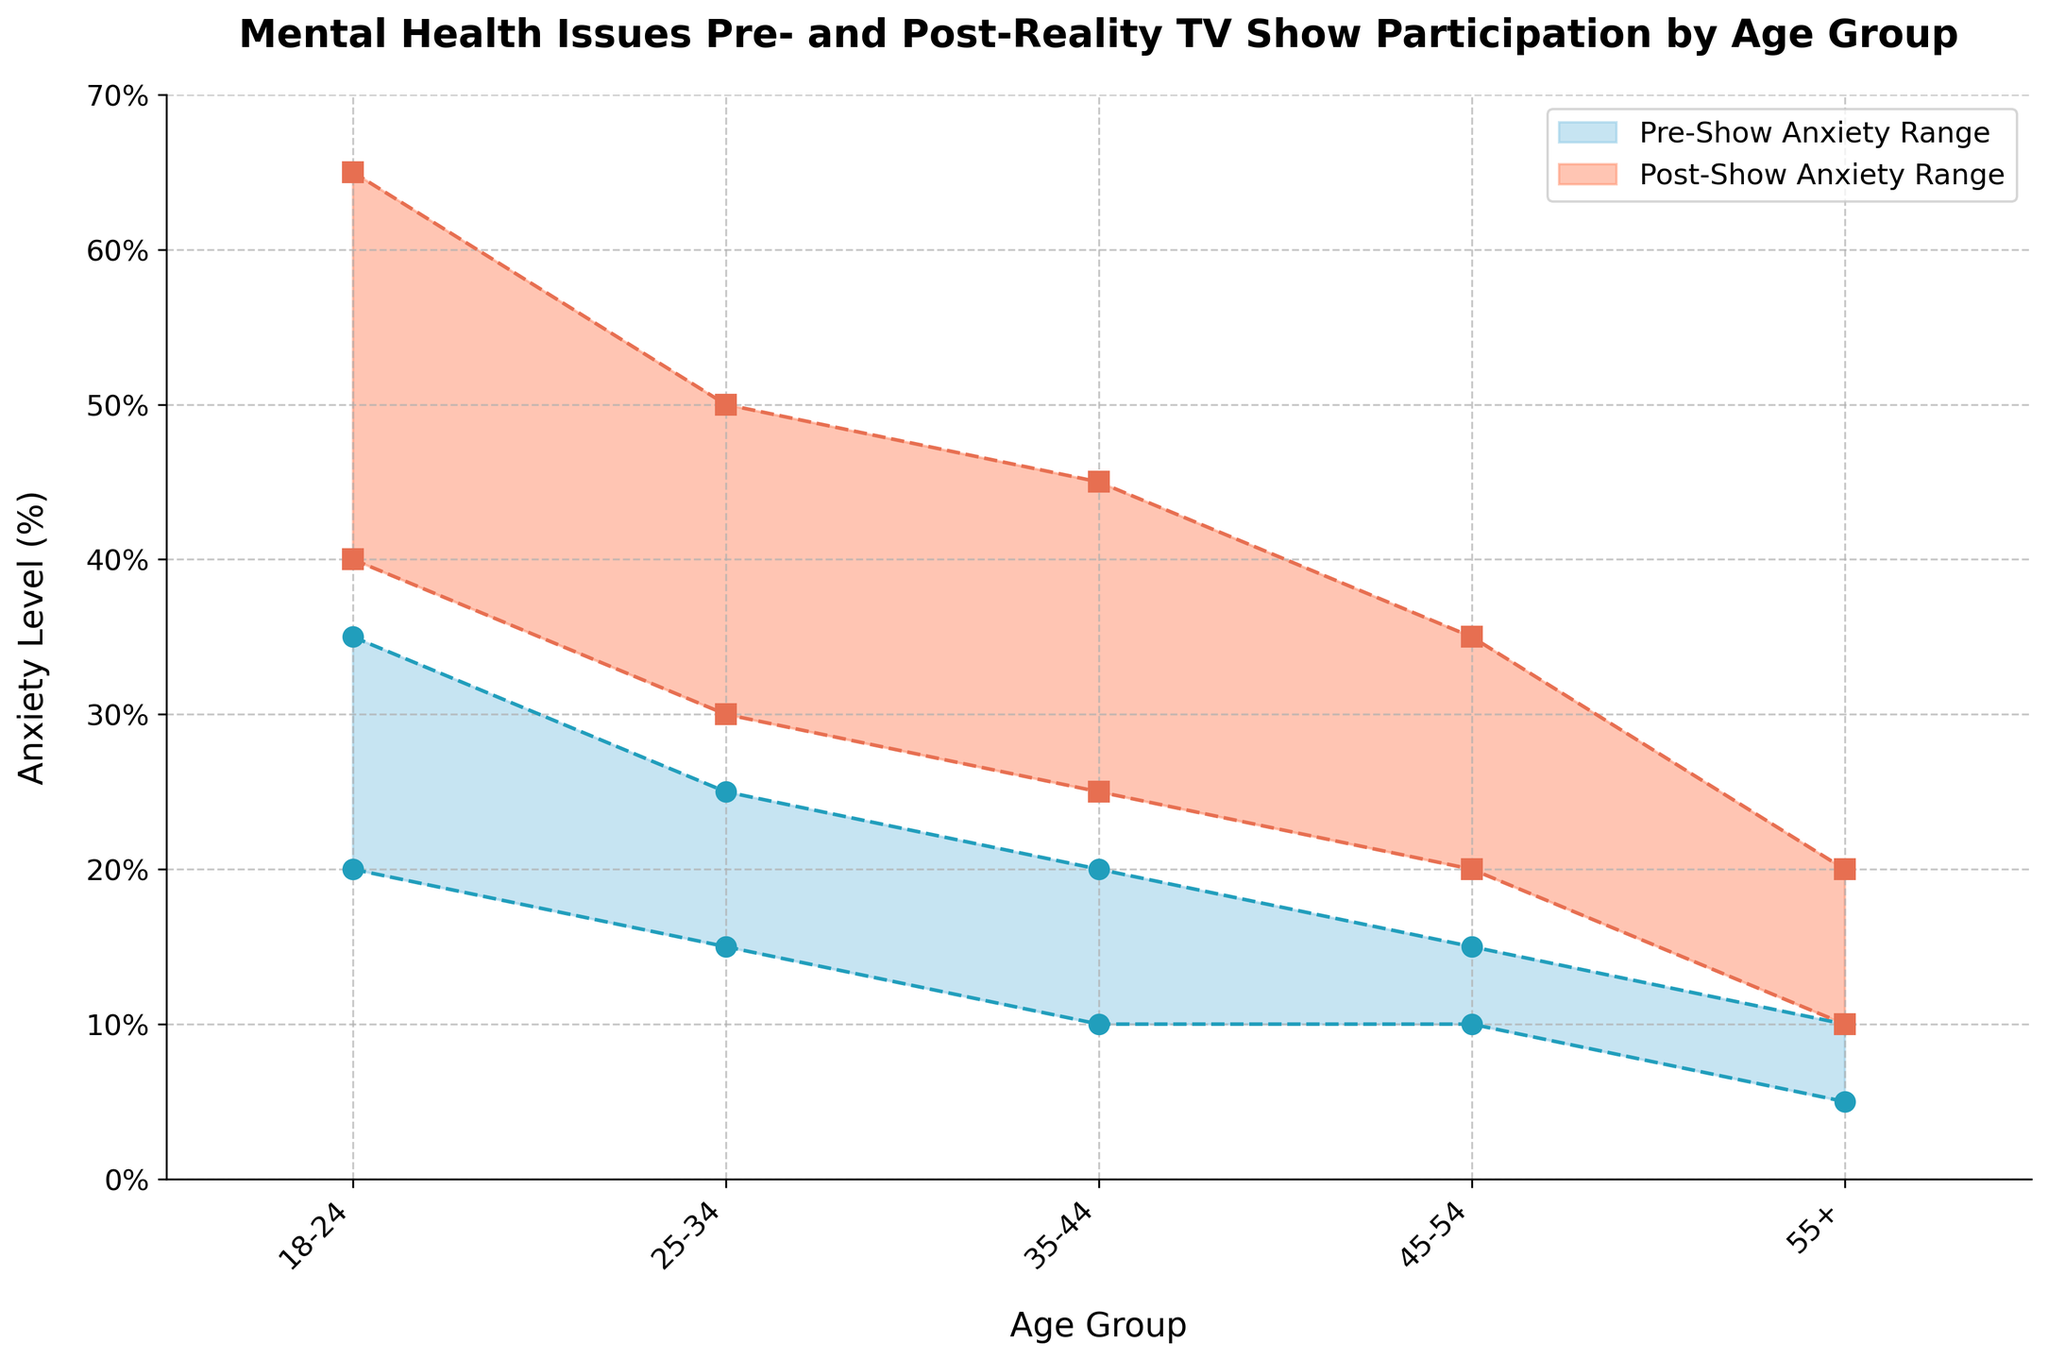What is the title of the plot? The title is located at the top of the figure with larger font size and bold formatting.
Answer: Mental Health Issues Pre- and Post-Reality TV Show Participation by Age Group What are the two ranges shown in the plot, and how are they labeled in the legend? The ranges are shaded areas, each labeled distinctly in the legend at the top right corner. The blue shaded area represents "Pre-Show Anxiety Range," and the orange shaded area represents "Post-Show Anxiety Range."
Answer: Pre-Show Anxiety Range, Post-Show Anxiety Range Which age group shows the highest minimum value of post-show anxiety? Examine the lower boundary (minimum value) of the orange shaded area and look for the highest point along the y-axis. For the 18-24 age group, the minimum post-show anxiety is 40%, which is the highest among all groups.
Answer: 18-24 How does the maximum value of pre-show anxiety for the 25-34 age group compare with the minimum value of post-show anxiety for the same group? Check the upper boundary (maximum value) of the blue shaded area and the lower boundary (minimum value) of the orange shaded area for the 25-34 age group. The maximum pre-show anxiety is 25%, while the minimum post-show anxiety is 30%.
Answer: The minimum post-show anxiety is higher What is the difference between the maximum pre-show and post-show anxiety for the 35-44 age group? Locate the top points of the shaded areas for the 35-44 age group to determine the maximum values. The pre-show maximum is 20%, and the post-show maximum is 45%, so the difference is 45% - 20% = 25%.
Answer: 25% What is the range (span) of post-show anxiety for the 55+ age group? Identify the lower and upper boundaries of the orange shaded area for the 55+ age group. The post-show anxiety ranges from 10% to 20%, thus the span is 20% - 10% = 10%.
Answer: 10% Which age group has the smallest increase in anxiety levels from pre- to post-show participation? Determine the difference between the minimum and maximum pre- and post-show anxiety values for each age group. For the 55+ age group, the pre-show anxiety range is 5%-10% and post-show range is 10%-20%, so the smallest increase is 10% compared to other groups.
Answer: 55+ How does the pre-show anxiety range compare to the post-show anxiety range for the 45-54 age group? For the 45-54 age group, calculate the spans separately: pre-show range is from 10% to 15% (5% span) and post-show range is from 20% to 35% (15% span). The post-show range is significantly wider by 15% - 5% = 10%.
Answer: Post-show range is wider by 10% What does the plot suggest about the impact of reality TV show participation on anxiety levels? The plot demonstrates that, across all age groups, the post-show anxiety ranges are consistently higher and wider than the pre-show ranges, indicating a general increase in anxiety levels after reality TV show participation.
Answer: Increase in anxiety levels 